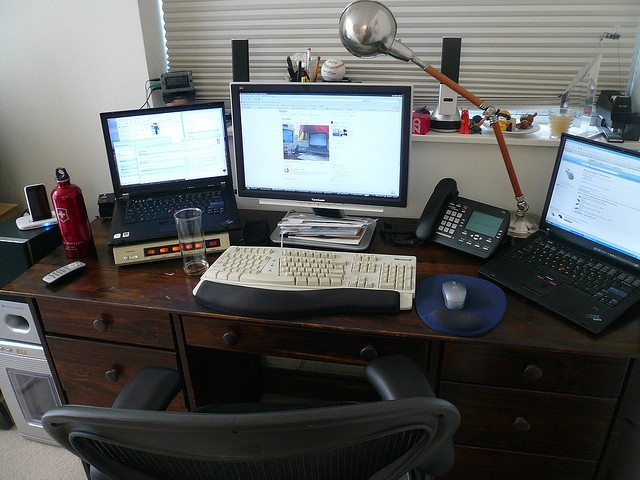Describe the objects in this image and their specific colors. I can see chair in lightgray, black, and purple tones, tv in lightgray, lightblue, black, gray, and darkgray tones, laptop in lightgray, black, lightblue, and navy tones, laptop in lightgray, white, black, navy, and lightblue tones, and keyboard in lightgray, black, and darkgray tones in this image. 